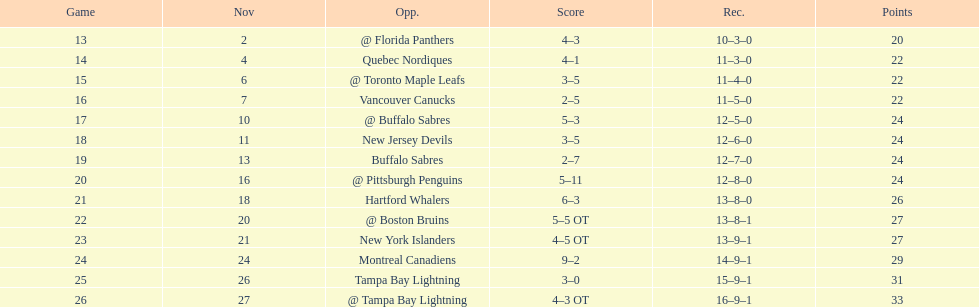What was the total penalty minutes that dave brown had on the 1993-1994 flyers? 137. 